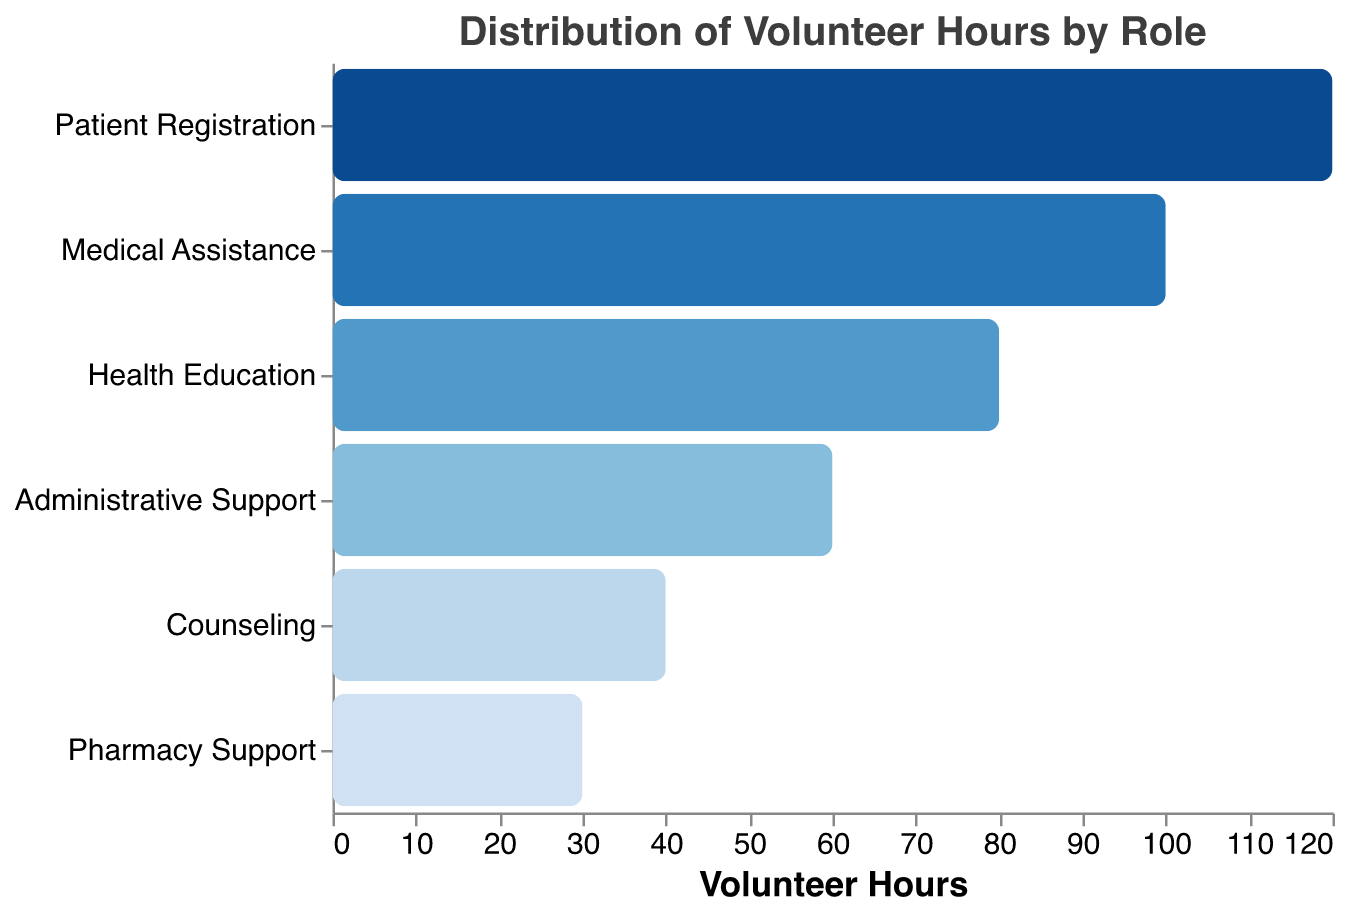What is the title of the figure? The title is usually displayed at the top of the figure, which in this case reads "Distribution of Volunteer Hours by Role".
Answer: Distribution of Volunteer Hours by Role How many roles are represented in the chart? Each bar in the funnel chart represents a different role. By counting the bars, we can determine there are six roles.
Answer: Six Which role has the highest number of volunteer hours? The role with the longest bar at the top of the funnel chart has the highest number of volunteer hours, which is Patient Registration with 120 hours.
Answer: Patient Registration What is the total number of volunteer hours for all roles combined? To find this, we sum up the hours for all roles: 120 (Patient Registration) + 100 (Medical Assistance) + 80 (Health Education) + 60 (Administrative Support) + 40 (Counseling) + 30 (Pharmacy Support) = 430 hours.
Answer: 430 hours How many more hours are devoted to Medical Assistance compared to Pharmacy Support? Subtract the hours for Pharmacy Support from Medical Assistance: 100 (Medical Assistance) - 30 (Pharmacy Support) = 70 hours.
Answer: 70 hours What is the percentage of total volunteer hours that Counseling contributes? First, find the total volunteer hours which is 430. Then, calculate the percentage contributed by Counseling: (40 / 430) * 100 = ~9.30%.
Answer: ~9.30% Which roles have fewer than 50 volunteer hours? Roles with bars having less than 50 hours are indicated as bottom items in the funnel chart. These are Counseling with 40 hours and Pharmacy Support with 30 hours.
Answer: Counseling and Pharmacy Support How many hours more are spent on Health Education compared to Administrative Support? Subtract the hours for Administrative Support from Health Education: 80 (Health Education) - 60 (Administrative Support) = 20 hours.
Answer: 20 hours Rank the roles from highest to lowest by the number of volunteer hours. The roles are ordered by the height of their bars from longest to shortest: Patient Registration (120), Medical Assistance (100), Health Education (80), Administrative Support (60), Counseling (40), Pharmacy Support (30).
Answer: Patient Registration, Medical Assistance, Health Education, Administrative Support, Counseling, Pharmacy Support 